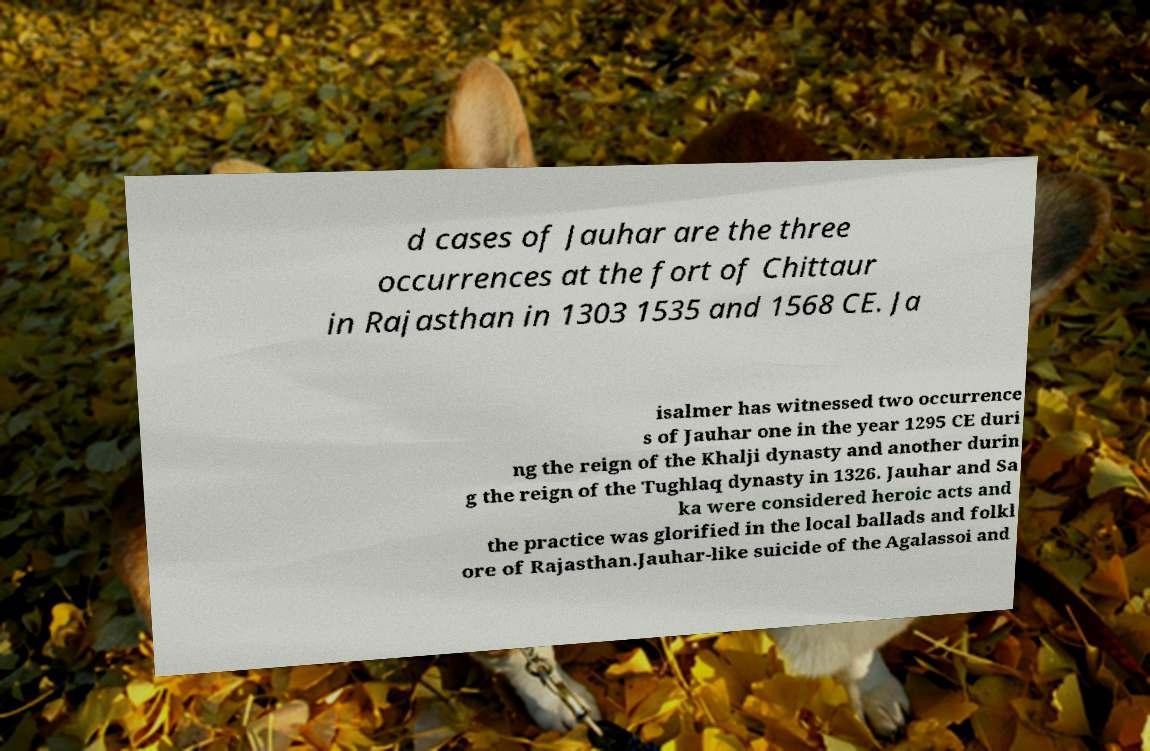I need the written content from this picture converted into text. Can you do that? d cases of Jauhar are the three occurrences at the fort of Chittaur in Rajasthan in 1303 1535 and 1568 CE. Ja isalmer has witnessed two occurrence s of Jauhar one in the year 1295 CE duri ng the reign of the Khalji dynasty and another durin g the reign of the Tughlaq dynasty in 1326. Jauhar and Sa ka were considered heroic acts and the practice was glorified in the local ballads and folkl ore of Rajasthan.Jauhar-like suicide of the Agalassoi and 